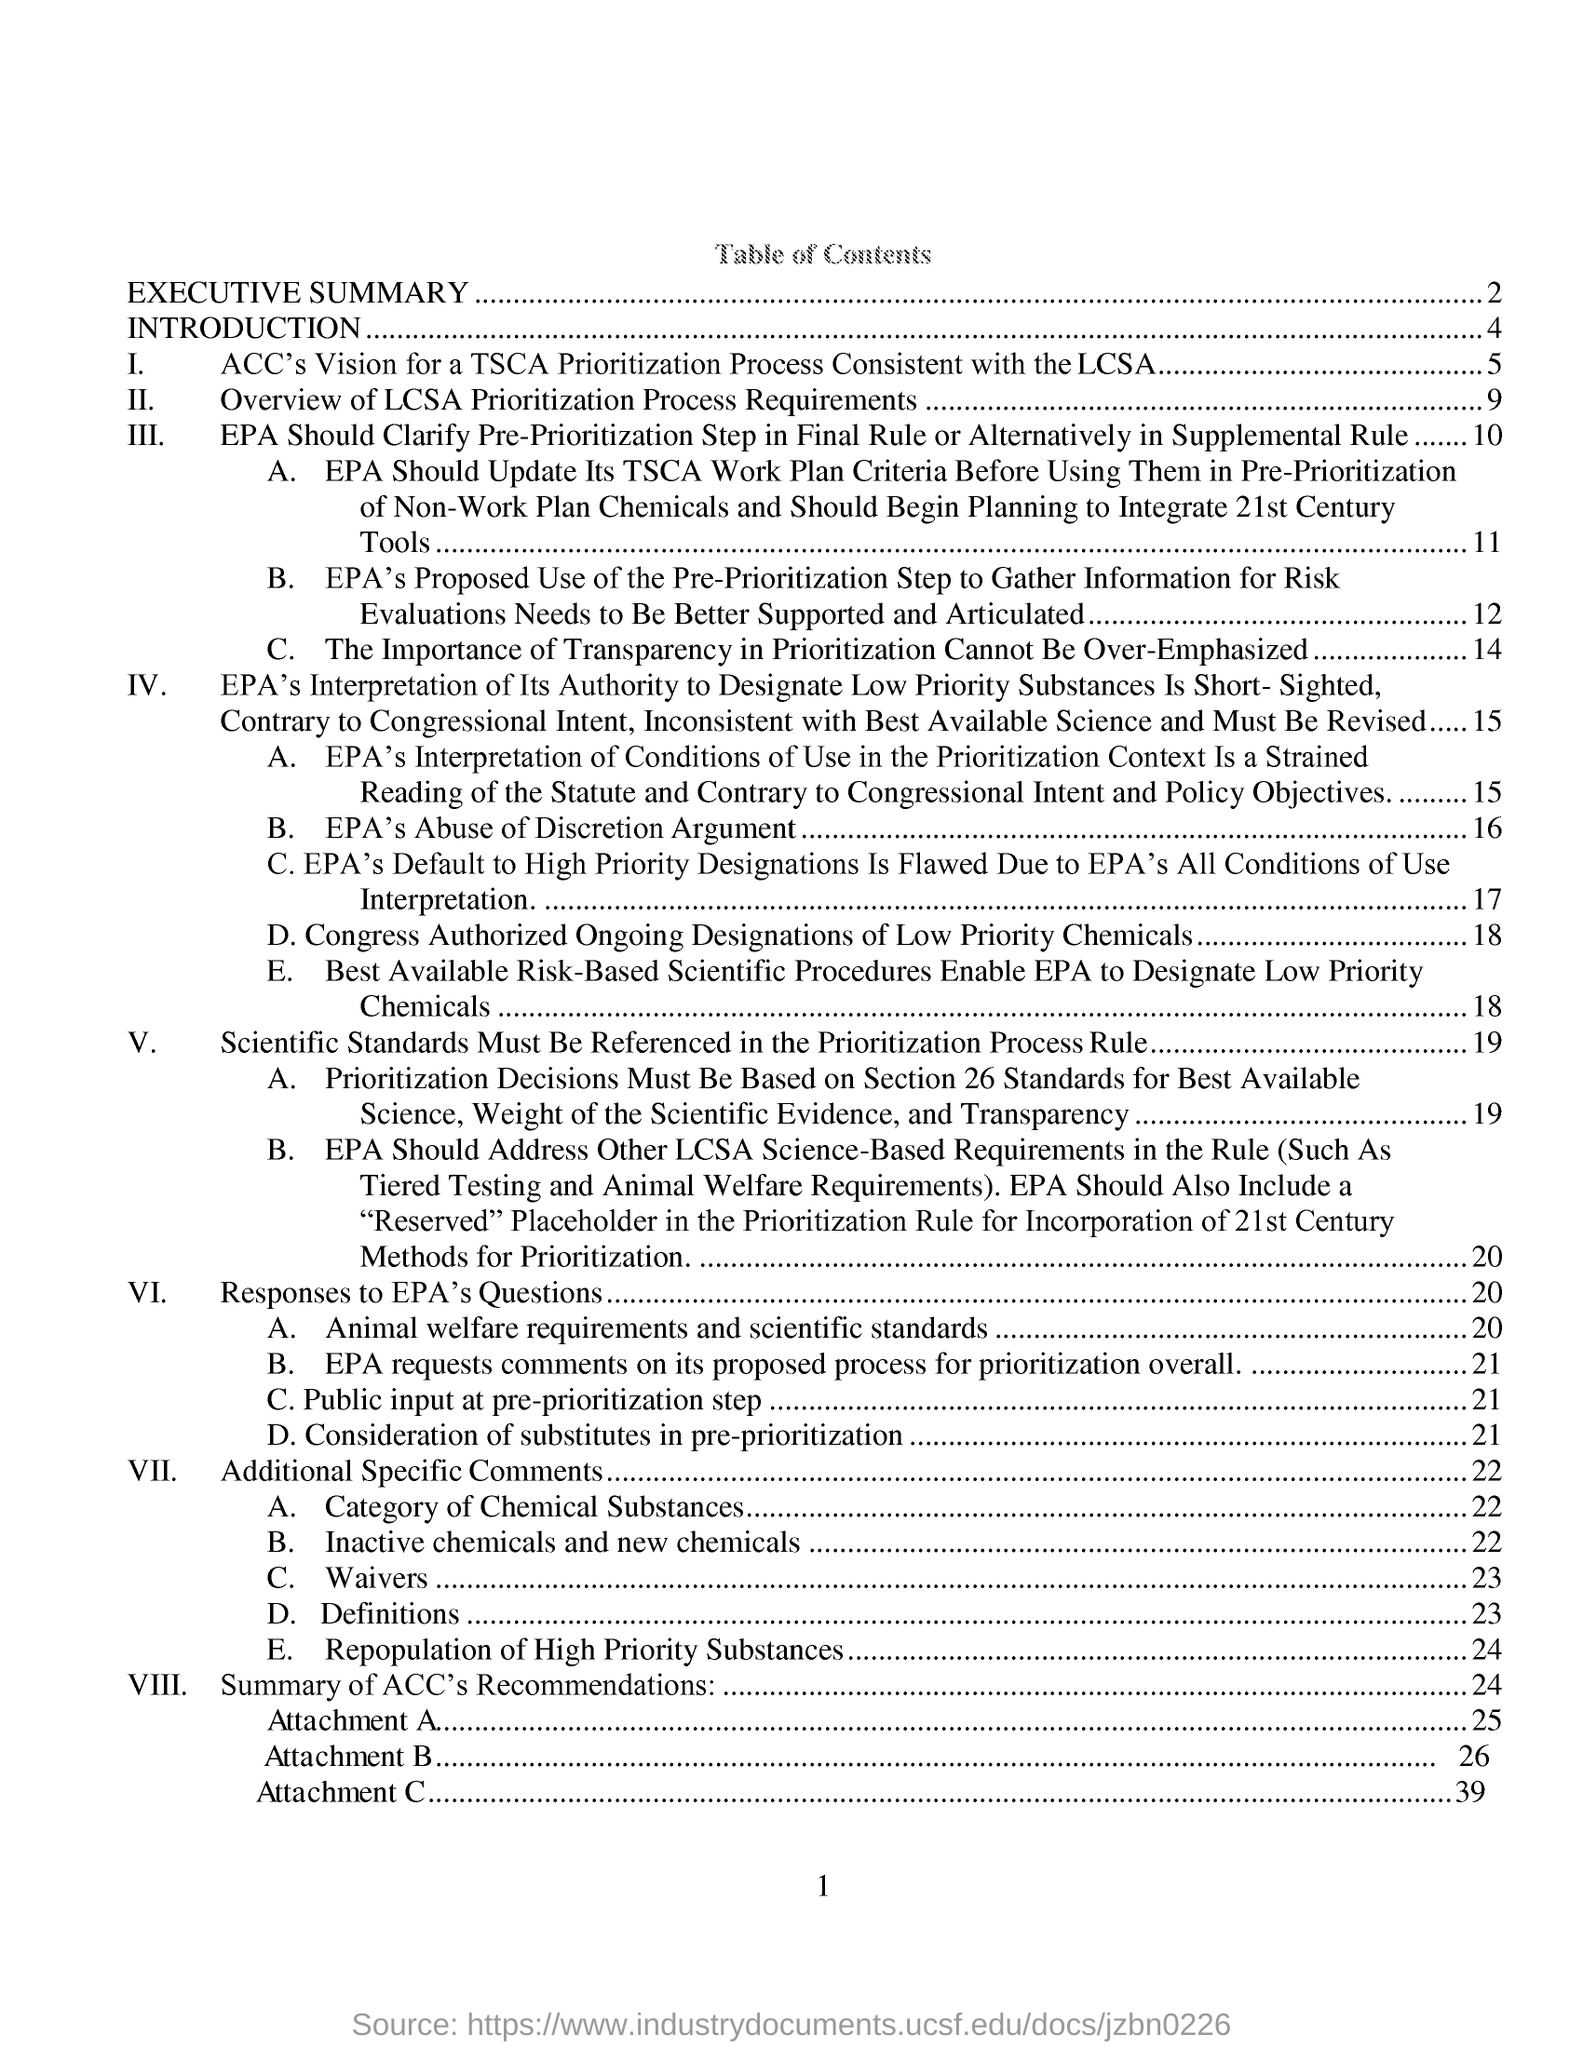Give some essential details in this illustration. ACC's vision for a TSCA prioritization process that is consistent with the Lautenberg Act is the first topic under the introduction. The first topic in the table of contents is "Executive Summary. The point VII is from page 22. 